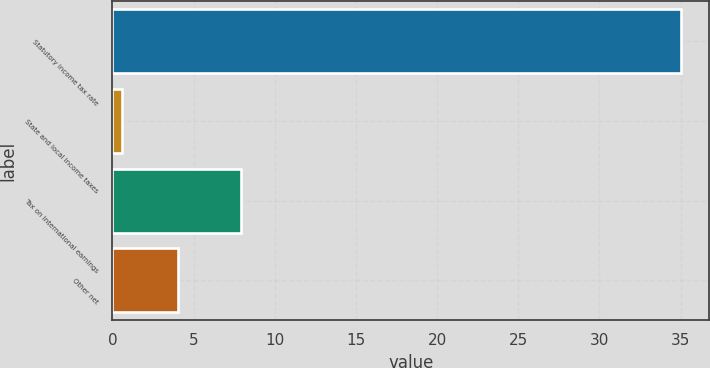<chart> <loc_0><loc_0><loc_500><loc_500><bar_chart><fcel>Statutory income tax rate<fcel>State and local income taxes<fcel>Tax on international earnings<fcel>Other net<nl><fcel>35<fcel>0.6<fcel>7.9<fcel>4.04<nl></chart> 